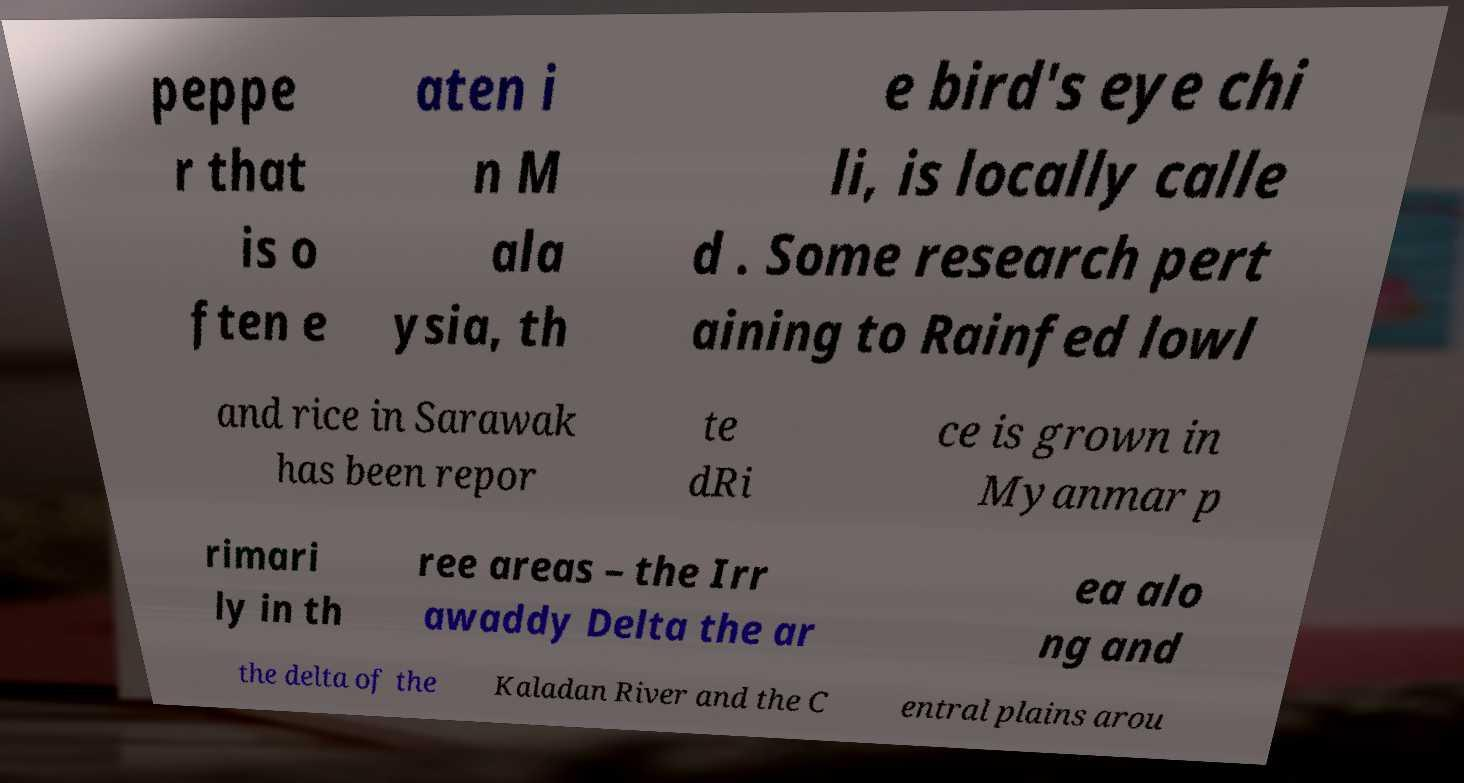Please read and relay the text visible in this image. What does it say? peppe r that is o ften e aten i n M ala ysia, th e bird's eye chi li, is locally calle d . Some research pert aining to Rainfed lowl and rice in Sarawak has been repor te dRi ce is grown in Myanmar p rimari ly in th ree areas – the Irr awaddy Delta the ar ea alo ng and the delta of the Kaladan River and the C entral plains arou 